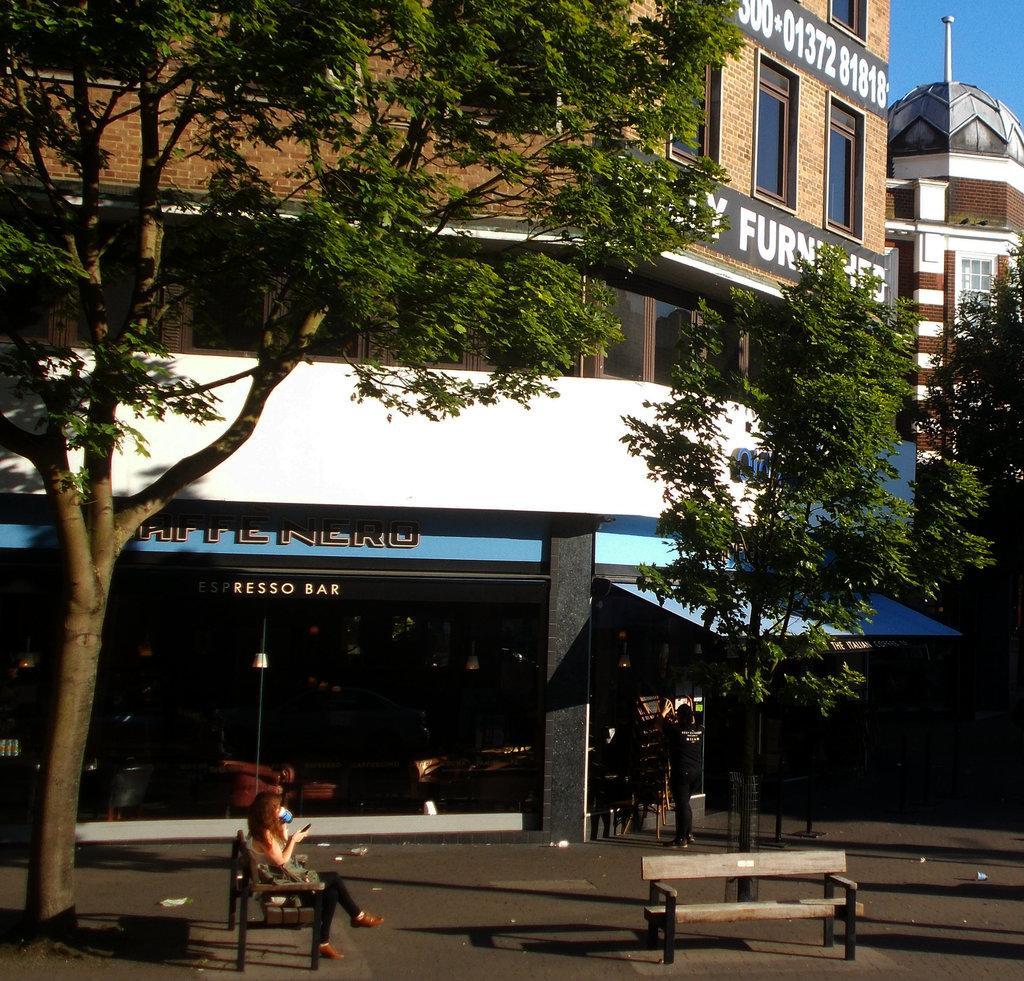Describe this image in one or two sentences. In this picture, There is a road which is in black color, In the right side there is a chair which is in white color, There are some green color trees, In the left side there is a woman sitting on a chair which is in brown color, in the background there is a shop. 